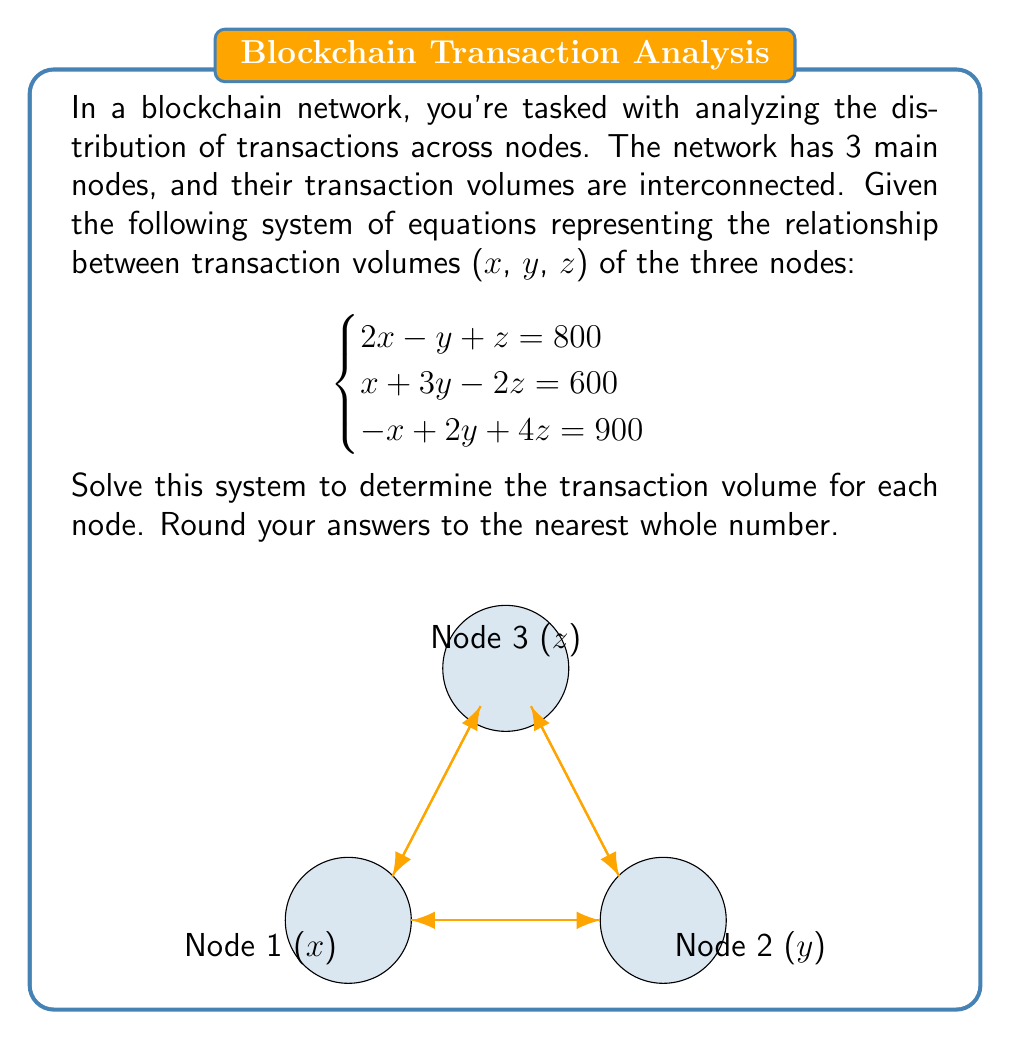Give your solution to this math problem. To solve this system of linear equations, we'll use the Gaussian elimination method:

1) First, write the augmented matrix:

$$\begin{bmatrix}
2 & -1 & 1 & | & 800 \\
1 & 3 & -2 & | & 600 \\
-1 & 2 & 4 & | & 900
\end{bmatrix}$$

2) Multiply the first row by -1/2 and add it to the second row:

$$\begin{bmatrix}
2 & -1 & 1 & | & 800 \\
0 & 3.5 & -2.5 & | & 200 \\
-1 & 2 & 4 & | & 900
\end{bmatrix}$$

3) Add the first row to the third row:

$$\begin{bmatrix}
2 & -1 & 1 & | & 800 \\
0 & 3.5 & -2.5 & | & 200 \\
0 & 1 & 5 & | & 1700
\end{bmatrix}$$

4) Multiply the second row by -2/7 and add it to the third row:

$$\begin{bmatrix}
2 & -1 & 1 & | & 800 \\
0 & 3.5 & -2.5 & | & 200 \\
0 & 0 & 5.714 & | & 1642.857
\end{bmatrix}$$

5) Now we have an upper triangular matrix. Solve for z:

$$z = 1642.857 / 5.714 \approx 287.5$$

6) Substitute z back into the second equation:

$$3.5y - 2.5(287.5) = 200$$
$$3.5y = 918.75$$
$$y = 262.5$$

7) Finally, substitute y and z into the first equation:

$$2x - 262.5 + 287.5 = 800$$
$$2x = 775$$
$$x = 387.5$$

8) Rounding to the nearest whole number:

x ≈ 388
y ≈ 263
z ≈ 288
Answer: (388, 263, 288) 